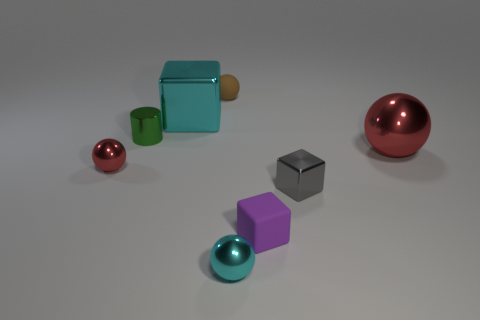Subtract all small brown matte spheres. How many spheres are left? 3 Subtract all blue cylinders. How many red spheres are left? 2 Subtract all brown balls. How many balls are left? 3 Add 1 tiny purple matte cubes. How many objects exist? 9 Subtract all cylinders. How many objects are left? 7 Add 6 brown spheres. How many brown spheres are left? 7 Add 5 green shiny blocks. How many green shiny blocks exist? 5 Subtract 0 purple cylinders. How many objects are left? 8 Subtract all red spheres. Subtract all red cylinders. How many spheres are left? 2 Subtract all big purple balls. Subtract all metallic balls. How many objects are left? 5 